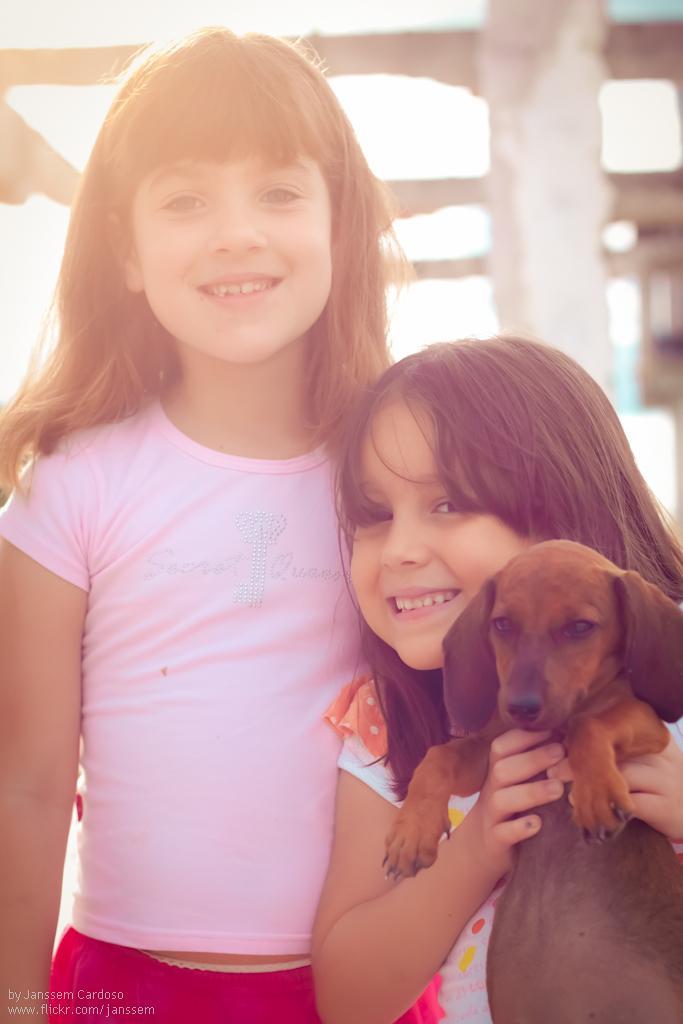How would you summarize this image in a sentence or two? In this picture there are two girls one is left side and another one is right side, and the girl who is at the right side of the image she is holding a dog in her hands. 